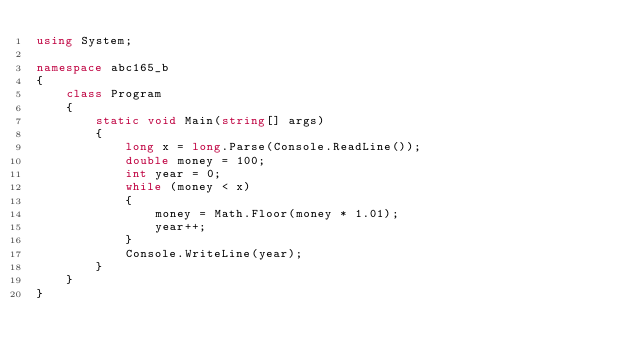Convert code to text. <code><loc_0><loc_0><loc_500><loc_500><_C#_>using System;

namespace abc165_b
{
    class Program
    {
        static void Main(string[] args)
        {
            long x = long.Parse(Console.ReadLine());
            double money = 100;
            int year = 0;
            while (money < x)
            {
                money = Math.Floor(money * 1.01);
                year++;
            }
            Console.WriteLine(year);
        }
    }
}
</code> 